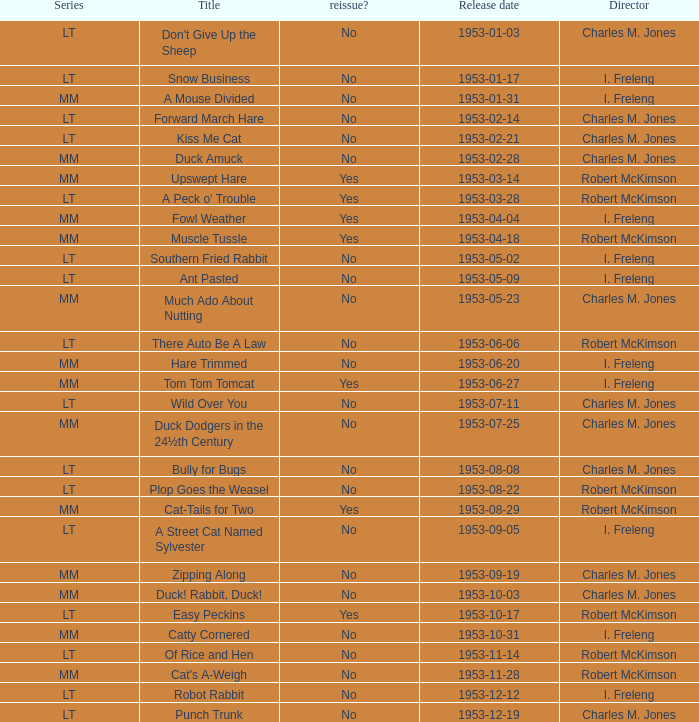What's the title for the release date of 1953-01-31 in the MM series, no reissue, and a director of I. Freleng? A Mouse Divided. 